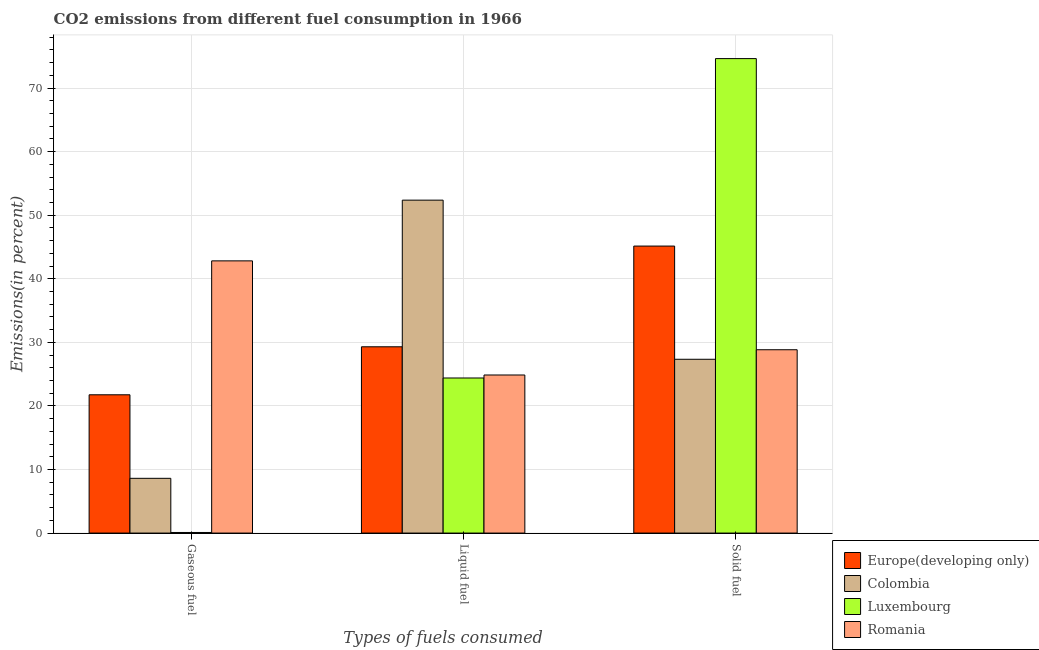How many groups of bars are there?
Your response must be concise. 3. Are the number of bars per tick equal to the number of legend labels?
Offer a very short reply. Yes. How many bars are there on the 1st tick from the right?
Provide a short and direct response. 4. What is the label of the 1st group of bars from the left?
Your answer should be compact. Gaseous fuel. What is the percentage of liquid fuel emission in Colombia?
Keep it short and to the point. 52.36. Across all countries, what is the maximum percentage of solid fuel emission?
Make the answer very short. 74.63. Across all countries, what is the minimum percentage of liquid fuel emission?
Your response must be concise. 24.39. In which country was the percentage of gaseous fuel emission maximum?
Your answer should be compact. Romania. In which country was the percentage of solid fuel emission minimum?
Your answer should be compact. Colombia. What is the total percentage of gaseous fuel emission in the graph?
Your response must be concise. 73.27. What is the difference between the percentage of gaseous fuel emission in Europe(developing only) and that in Luxembourg?
Make the answer very short. 21.65. What is the difference between the percentage of liquid fuel emission in Luxembourg and the percentage of gaseous fuel emission in Romania?
Ensure brevity in your answer.  -18.42. What is the average percentage of solid fuel emission per country?
Ensure brevity in your answer.  43.99. What is the difference between the percentage of liquid fuel emission and percentage of gaseous fuel emission in Colombia?
Offer a very short reply. 43.75. In how many countries, is the percentage of solid fuel emission greater than 6 %?
Your answer should be compact. 4. What is the ratio of the percentage of solid fuel emission in Romania to that in Luxembourg?
Provide a succinct answer. 0.39. Is the percentage of solid fuel emission in Romania less than that in Colombia?
Provide a short and direct response. No. Is the difference between the percentage of gaseous fuel emission in Luxembourg and Colombia greater than the difference between the percentage of solid fuel emission in Luxembourg and Colombia?
Keep it short and to the point. No. What is the difference between the highest and the second highest percentage of gaseous fuel emission?
Ensure brevity in your answer.  21.07. What is the difference between the highest and the lowest percentage of gaseous fuel emission?
Your answer should be very brief. 42.72. In how many countries, is the percentage of liquid fuel emission greater than the average percentage of liquid fuel emission taken over all countries?
Your response must be concise. 1. Is the sum of the percentage of gaseous fuel emission in Romania and Colombia greater than the maximum percentage of solid fuel emission across all countries?
Provide a short and direct response. No. What does the 4th bar from the left in Solid fuel represents?
Provide a short and direct response. Romania. What does the 2nd bar from the right in Solid fuel represents?
Make the answer very short. Luxembourg. Is it the case that in every country, the sum of the percentage of gaseous fuel emission and percentage of liquid fuel emission is greater than the percentage of solid fuel emission?
Offer a terse response. No. How many bars are there?
Ensure brevity in your answer.  12. Are the values on the major ticks of Y-axis written in scientific E-notation?
Your answer should be compact. No. Does the graph contain any zero values?
Offer a very short reply. No. What is the title of the graph?
Your answer should be very brief. CO2 emissions from different fuel consumption in 1966. What is the label or title of the X-axis?
Ensure brevity in your answer.  Types of fuels consumed. What is the label or title of the Y-axis?
Your answer should be compact. Emissions(in percent). What is the Emissions(in percent) in Europe(developing only) in Gaseous fuel?
Your answer should be very brief. 21.75. What is the Emissions(in percent) of Colombia in Gaseous fuel?
Your response must be concise. 8.61. What is the Emissions(in percent) in Luxembourg in Gaseous fuel?
Keep it short and to the point. 0.09. What is the Emissions(in percent) of Romania in Gaseous fuel?
Provide a short and direct response. 42.81. What is the Emissions(in percent) of Europe(developing only) in Liquid fuel?
Provide a succinct answer. 29.3. What is the Emissions(in percent) of Colombia in Liquid fuel?
Your answer should be very brief. 52.36. What is the Emissions(in percent) in Luxembourg in Liquid fuel?
Offer a very short reply. 24.39. What is the Emissions(in percent) in Romania in Liquid fuel?
Provide a succinct answer. 24.86. What is the Emissions(in percent) of Europe(developing only) in Solid fuel?
Your response must be concise. 45.14. What is the Emissions(in percent) of Colombia in Solid fuel?
Offer a very short reply. 27.34. What is the Emissions(in percent) in Luxembourg in Solid fuel?
Provide a short and direct response. 74.63. What is the Emissions(in percent) in Romania in Solid fuel?
Ensure brevity in your answer.  28.84. Across all Types of fuels consumed, what is the maximum Emissions(in percent) in Europe(developing only)?
Offer a terse response. 45.14. Across all Types of fuels consumed, what is the maximum Emissions(in percent) in Colombia?
Offer a very short reply. 52.36. Across all Types of fuels consumed, what is the maximum Emissions(in percent) in Luxembourg?
Your response must be concise. 74.63. Across all Types of fuels consumed, what is the maximum Emissions(in percent) of Romania?
Ensure brevity in your answer.  42.81. Across all Types of fuels consumed, what is the minimum Emissions(in percent) in Europe(developing only)?
Provide a succinct answer. 21.75. Across all Types of fuels consumed, what is the minimum Emissions(in percent) of Colombia?
Give a very brief answer. 8.61. Across all Types of fuels consumed, what is the minimum Emissions(in percent) of Luxembourg?
Provide a short and direct response. 0.09. Across all Types of fuels consumed, what is the minimum Emissions(in percent) in Romania?
Make the answer very short. 24.86. What is the total Emissions(in percent) in Europe(developing only) in the graph?
Your answer should be very brief. 96.19. What is the total Emissions(in percent) in Colombia in the graph?
Ensure brevity in your answer.  88.31. What is the total Emissions(in percent) of Luxembourg in the graph?
Your answer should be compact. 99.12. What is the total Emissions(in percent) of Romania in the graph?
Provide a short and direct response. 96.52. What is the difference between the Emissions(in percent) of Europe(developing only) in Gaseous fuel and that in Liquid fuel?
Provide a succinct answer. -7.55. What is the difference between the Emissions(in percent) in Colombia in Gaseous fuel and that in Liquid fuel?
Your answer should be compact. -43.75. What is the difference between the Emissions(in percent) in Luxembourg in Gaseous fuel and that in Liquid fuel?
Your response must be concise. -24.3. What is the difference between the Emissions(in percent) of Romania in Gaseous fuel and that in Liquid fuel?
Keep it short and to the point. 17.95. What is the difference between the Emissions(in percent) of Europe(developing only) in Gaseous fuel and that in Solid fuel?
Keep it short and to the point. -23.39. What is the difference between the Emissions(in percent) of Colombia in Gaseous fuel and that in Solid fuel?
Your answer should be very brief. -18.72. What is the difference between the Emissions(in percent) in Luxembourg in Gaseous fuel and that in Solid fuel?
Keep it short and to the point. -74.53. What is the difference between the Emissions(in percent) of Romania in Gaseous fuel and that in Solid fuel?
Your answer should be compact. 13.98. What is the difference between the Emissions(in percent) in Europe(developing only) in Liquid fuel and that in Solid fuel?
Your response must be concise. -15.84. What is the difference between the Emissions(in percent) in Colombia in Liquid fuel and that in Solid fuel?
Offer a terse response. 25.03. What is the difference between the Emissions(in percent) in Luxembourg in Liquid fuel and that in Solid fuel?
Make the answer very short. -50.24. What is the difference between the Emissions(in percent) in Romania in Liquid fuel and that in Solid fuel?
Offer a terse response. -3.97. What is the difference between the Emissions(in percent) in Europe(developing only) in Gaseous fuel and the Emissions(in percent) in Colombia in Liquid fuel?
Provide a succinct answer. -30.61. What is the difference between the Emissions(in percent) of Europe(developing only) in Gaseous fuel and the Emissions(in percent) of Luxembourg in Liquid fuel?
Your answer should be very brief. -2.64. What is the difference between the Emissions(in percent) in Europe(developing only) in Gaseous fuel and the Emissions(in percent) in Romania in Liquid fuel?
Offer a terse response. -3.11. What is the difference between the Emissions(in percent) of Colombia in Gaseous fuel and the Emissions(in percent) of Luxembourg in Liquid fuel?
Provide a short and direct response. -15.78. What is the difference between the Emissions(in percent) in Colombia in Gaseous fuel and the Emissions(in percent) in Romania in Liquid fuel?
Give a very brief answer. -16.25. What is the difference between the Emissions(in percent) of Luxembourg in Gaseous fuel and the Emissions(in percent) of Romania in Liquid fuel?
Your response must be concise. -24.77. What is the difference between the Emissions(in percent) in Europe(developing only) in Gaseous fuel and the Emissions(in percent) in Colombia in Solid fuel?
Provide a succinct answer. -5.59. What is the difference between the Emissions(in percent) in Europe(developing only) in Gaseous fuel and the Emissions(in percent) in Luxembourg in Solid fuel?
Make the answer very short. -52.88. What is the difference between the Emissions(in percent) in Europe(developing only) in Gaseous fuel and the Emissions(in percent) in Romania in Solid fuel?
Give a very brief answer. -7.09. What is the difference between the Emissions(in percent) of Colombia in Gaseous fuel and the Emissions(in percent) of Luxembourg in Solid fuel?
Your response must be concise. -66.02. What is the difference between the Emissions(in percent) in Colombia in Gaseous fuel and the Emissions(in percent) in Romania in Solid fuel?
Offer a terse response. -20.22. What is the difference between the Emissions(in percent) of Luxembourg in Gaseous fuel and the Emissions(in percent) of Romania in Solid fuel?
Offer a terse response. -28.74. What is the difference between the Emissions(in percent) of Europe(developing only) in Liquid fuel and the Emissions(in percent) of Colombia in Solid fuel?
Provide a succinct answer. 1.96. What is the difference between the Emissions(in percent) of Europe(developing only) in Liquid fuel and the Emissions(in percent) of Luxembourg in Solid fuel?
Offer a terse response. -45.33. What is the difference between the Emissions(in percent) in Europe(developing only) in Liquid fuel and the Emissions(in percent) in Romania in Solid fuel?
Give a very brief answer. 0.46. What is the difference between the Emissions(in percent) of Colombia in Liquid fuel and the Emissions(in percent) of Luxembourg in Solid fuel?
Offer a very short reply. -22.27. What is the difference between the Emissions(in percent) of Colombia in Liquid fuel and the Emissions(in percent) of Romania in Solid fuel?
Your answer should be very brief. 23.53. What is the difference between the Emissions(in percent) of Luxembourg in Liquid fuel and the Emissions(in percent) of Romania in Solid fuel?
Provide a succinct answer. -4.44. What is the average Emissions(in percent) of Europe(developing only) per Types of fuels consumed?
Make the answer very short. 32.06. What is the average Emissions(in percent) in Colombia per Types of fuels consumed?
Give a very brief answer. 29.44. What is the average Emissions(in percent) of Luxembourg per Types of fuels consumed?
Offer a terse response. 33.04. What is the average Emissions(in percent) of Romania per Types of fuels consumed?
Ensure brevity in your answer.  32.17. What is the difference between the Emissions(in percent) in Europe(developing only) and Emissions(in percent) in Colombia in Gaseous fuel?
Provide a succinct answer. 13.14. What is the difference between the Emissions(in percent) of Europe(developing only) and Emissions(in percent) of Luxembourg in Gaseous fuel?
Provide a short and direct response. 21.65. What is the difference between the Emissions(in percent) of Europe(developing only) and Emissions(in percent) of Romania in Gaseous fuel?
Provide a succinct answer. -21.07. What is the difference between the Emissions(in percent) in Colombia and Emissions(in percent) in Luxembourg in Gaseous fuel?
Provide a short and direct response. 8.52. What is the difference between the Emissions(in percent) of Colombia and Emissions(in percent) of Romania in Gaseous fuel?
Your answer should be very brief. -34.2. What is the difference between the Emissions(in percent) of Luxembourg and Emissions(in percent) of Romania in Gaseous fuel?
Provide a succinct answer. -42.72. What is the difference between the Emissions(in percent) of Europe(developing only) and Emissions(in percent) of Colombia in Liquid fuel?
Provide a succinct answer. -23.06. What is the difference between the Emissions(in percent) in Europe(developing only) and Emissions(in percent) in Luxembourg in Liquid fuel?
Your answer should be very brief. 4.91. What is the difference between the Emissions(in percent) in Europe(developing only) and Emissions(in percent) in Romania in Liquid fuel?
Ensure brevity in your answer.  4.44. What is the difference between the Emissions(in percent) in Colombia and Emissions(in percent) in Luxembourg in Liquid fuel?
Give a very brief answer. 27.97. What is the difference between the Emissions(in percent) of Luxembourg and Emissions(in percent) of Romania in Liquid fuel?
Offer a terse response. -0.47. What is the difference between the Emissions(in percent) of Europe(developing only) and Emissions(in percent) of Colombia in Solid fuel?
Provide a short and direct response. 17.81. What is the difference between the Emissions(in percent) in Europe(developing only) and Emissions(in percent) in Luxembourg in Solid fuel?
Keep it short and to the point. -29.49. What is the difference between the Emissions(in percent) of Europe(developing only) and Emissions(in percent) of Romania in Solid fuel?
Provide a succinct answer. 16.31. What is the difference between the Emissions(in percent) in Colombia and Emissions(in percent) in Luxembourg in Solid fuel?
Keep it short and to the point. -47.29. What is the difference between the Emissions(in percent) in Colombia and Emissions(in percent) in Romania in Solid fuel?
Provide a short and direct response. -1.5. What is the difference between the Emissions(in percent) of Luxembourg and Emissions(in percent) of Romania in Solid fuel?
Give a very brief answer. 45.79. What is the ratio of the Emissions(in percent) in Europe(developing only) in Gaseous fuel to that in Liquid fuel?
Offer a terse response. 0.74. What is the ratio of the Emissions(in percent) in Colombia in Gaseous fuel to that in Liquid fuel?
Offer a terse response. 0.16. What is the ratio of the Emissions(in percent) of Luxembourg in Gaseous fuel to that in Liquid fuel?
Keep it short and to the point. 0. What is the ratio of the Emissions(in percent) in Romania in Gaseous fuel to that in Liquid fuel?
Ensure brevity in your answer.  1.72. What is the ratio of the Emissions(in percent) of Europe(developing only) in Gaseous fuel to that in Solid fuel?
Your answer should be very brief. 0.48. What is the ratio of the Emissions(in percent) in Colombia in Gaseous fuel to that in Solid fuel?
Ensure brevity in your answer.  0.32. What is the ratio of the Emissions(in percent) of Luxembourg in Gaseous fuel to that in Solid fuel?
Provide a succinct answer. 0. What is the ratio of the Emissions(in percent) in Romania in Gaseous fuel to that in Solid fuel?
Your answer should be very brief. 1.48. What is the ratio of the Emissions(in percent) in Europe(developing only) in Liquid fuel to that in Solid fuel?
Provide a succinct answer. 0.65. What is the ratio of the Emissions(in percent) of Colombia in Liquid fuel to that in Solid fuel?
Give a very brief answer. 1.92. What is the ratio of the Emissions(in percent) of Luxembourg in Liquid fuel to that in Solid fuel?
Ensure brevity in your answer.  0.33. What is the ratio of the Emissions(in percent) in Romania in Liquid fuel to that in Solid fuel?
Provide a short and direct response. 0.86. What is the difference between the highest and the second highest Emissions(in percent) of Europe(developing only)?
Keep it short and to the point. 15.84. What is the difference between the highest and the second highest Emissions(in percent) of Colombia?
Provide a succinct answer. 25.03. What is the difference between the highest and the second highest Emissions(in percent) of Luxembourg?
Make the answer very short. 50.24. What is the difference between the highest and the second highest Emissions(in percent) of Romania?
Your response must be concise. 13.98. What is the difference between the highest and the lowest Emissions(in percent) in Europe(developing only)?
Provide a succinct answer. 23.39. What is the difference between the highest and the lowest Emissions(in percent) of Colombia?
Your answer should be very brief. 43.75. What is the difference between the highest and the lowest Emissions(in percent) of Luxembourg?
Keep it short and to the point. 74.53. What is the difference between the highest and the lowest Emissions(in percent) of Romania?
Give a very brief answer. 17.95. 